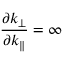<formula> <loc_0><loc_0><loc_500><loc_500>\frac { \partial k _ { \bot } } { \partial k _ { \| } } = \infty</formula> 